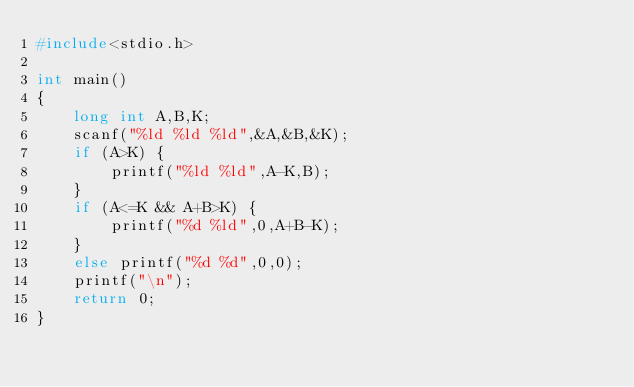<code> <loc_0><loc_0><loc_500><loc_500><_C_>#include<stdio.h>

int main()
{
    long int A,B,K;
    scanf("%ld %ld %ld",&A,&B,&K);
    if (A>K) {
        printf("%ld %ld",A-K,B);
    }
    if (A<=K && A+B>K) {
        printf("%d %ld",0,A+B-K);
    }
    else printf("%d %d",0,0);
    printf("\n");
    return 0;
}</code> 